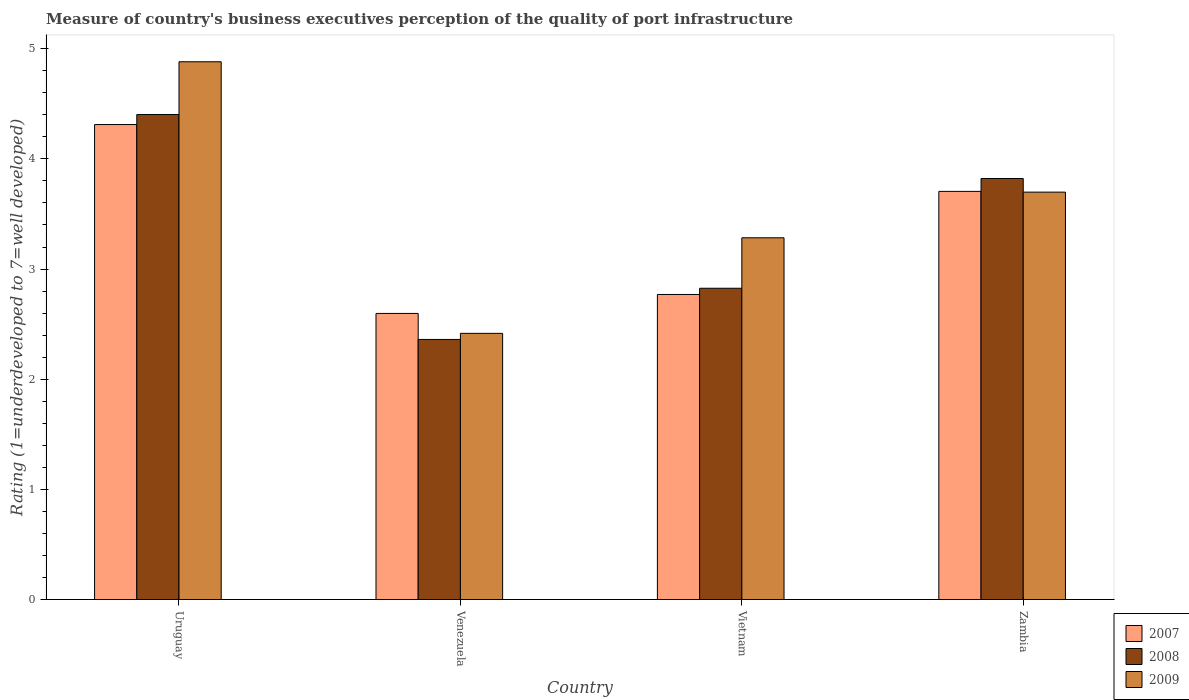How many different coloured bars are there?
Offer a very short reply. 3. How many groups of bars are there?
Keep it short and to the point. 4. Are the number of bars per tick equal to the number of legend labels?
Your answer should be compact. Yes. Are the number of bars on each tick of the X-axis equal?
Offer a very short reply. Yes. How many bars are there on the 1st tick from the right?
Keep it short and to the point. 3. What is the label of the 4th group of bars from the left?
Your answer should be very brief. Zambia. What is the ratings of the quality of port infrastructure in 2007 in Uruguay?
Your answer should be compact. 4.31. Across all countries, what is the maximum ratings of the quality of port infrastructure in 2007?
Offer a terse response. 4.31. Across all countries, what is the minimum ratings of the quality of port infrastructure in 2008?
Your response must be concise. 2.36. In which country was the ratings of the quality of port infrastructure in 2007 maximum?
Your response must be concise. Uruguay. In which country was the ratings of the quality of port infrastructure in 2007 minimum?
Give a very brief answer. Venezuela. What is the total ratings of the quality of port infrastructure in 2007 in the graph?
Provide a short and direct response. 13.38. What is the difference between the ratings of the quality of port infrastructure in 2009 in Uruguay and that in Zambia?
Your response must be concise. 1.18. What is the difference between the ratings of the quality of port infrastructure in 2007 in Venezuela and the ratings of the quality of port infrastructure in 2009 in Zambia?
Make the answer very short. -1.1. What is the average ratings of the quality of port infrastructure in 2009 per country?
Your answer should be compact. 3.57. What is the difference between the ratings of the quality of port infrastructure of/in 2009 and ratings of the quality of port infrastructure of/in 2008 in Vietnam?
Offer a very short reply. 0.46. In how many countries, is the ratings of the quality of port infrastructure in 2007 greater than 0.2?
Offer a terse response. 4. What is the ratio of the ratings of the quality of port infrastructure in 2009 in Uruguay to that in Vietnam?
Your answer should be very brief. 1.49. Is the ratings of the quality of port infrastructure in 2007 in Uruguay less than that in Venezuela?
Give a very brief answer. No. What is the difference between the highest and the second highest ratings of the quality of port infrastructure in 2007?
Provide a short and direct response. -0.94. What is the difference between the highest and the lowest ratings of the quality of port infrastructure in 2007?
Make the answer very short. 1.71. In how many countries, is the ratings of the quality of port infrastructure in 2007 greater than the average ratings of the quality of port infrastructure in 2007 taken over all countries?
Offer a terse response. 2. Is the sum of the ratings of the quality of port infrastructure in 2007 in Uruguay and Venezuela greater than the maximum ratings of the quality of port infrastructure in 2008 across all countries?
Make the answer very short. Yes. How many bars are there?
Make the answer very short. 12. Are all the bars in the graph horizontal?
Your response must be concise. No. Are the values on the major ticks of Y-axis written in scientific E-notation?
Provide a short and direct response. No. How are the legend labels stacked?
Provide a succinct answer. Vertical. What is the title of the graph?
Keep it short and to the point. Measure of country's business executives perception of the quality of port infrastructure. Does "1990" appear as one of the legend labels in the graph?
Give a very brief answer. No. What is the label or title of the Y-axis?
Ensure brevity in your answer.  Rating (1=underdeveloped to 7=well developed). What is the Rating (1=underdeveloped to 7=well developed) in 2007 in Uruguay?
Make the answer very short. 4.31. What is the Rating (1=underdeveloped to 7=well developed) in 2008 in Uruguay?
Your answer should be very brief. 4.4. What is the Rating (1=underdeveloped to 7=well developed) in 2009 in Uruguay?
Offer a very short reply. 4.88. What is the Rating (1=underdeveloped to 7=well developed) of 2007 in Venezuela?
Your answer should be compact. 2.6. What is the Rating (1=underdeveloped to 7=well developed) of 2008 in Venezuela?
Provide a succinct answer. 2.36. What is the Rating (1=underdeveloped to 7=well developed) of 2009 in Venezuela?
Provide a short and direct response. 2.42. What is the Rating (1=underdeveloped to 7=well developed) in 2007 in Vietnam?
Ensure brevity in your answer.  2.77. What is the Rating (1=underdeveloped to 7=well developed) of 2008 in Vietnam?
Provide a short and direct response. 2.83. What is the Rating (1=underdeveloped to 7=well developed) in 2009 in Vietnam?
Offer a terse response. 3.28. What is the Rating (1=underdeveloped to 7=well developed) in 2007 in Zambia?
Your answer should be compact. 3.7. What is the Rating (1=underdeveloped to 7=well developed) of 2008 in Zambia?
Ensure brevity in your answer.  3.82. What is the Rating (1=underdeveloped to 7=well developed) in 2009 in Zambia?
Your response must be concise. 3.7. Across all countries, what is the maximum Rating (1=underdeveloped to 7=well developed) in 2007?
Your answer should be very brief. 4.31. Across all countries, what is the maximum Rating (1=underdeveloped to 7=well developed) in 2008?
Your response must be concise. 4.4. Across all countries, what is the maximum Rating (1=underdeveloped to 7=well developed) in 2009?
Offer a terse response. 4.88. Across all countries, what is the minimum Rating (1=underdeveloped to 7=well developed) in 2007?
Your answer should be compact. 2.6. Across all countries, what is the minimum Rating (1=underdeveloped to 7=well developed) in 2008?
Ensure brevity in your answer.  2.36. Across all countries, what is the minimum Rating (1=underdeveloped to 7=well developed) in 2009?
Keep it short and to the point. 2.42. What is the total Rating (1=underdeveloped to 7=well developed) in 2007 in the graph?
Keep it short and to the point. 13.38. What is the total Rating (1=underdeveloped to 7=well developed) of 2008 in the graph?
Your answer should be compact. 13.41. What is the total Rating (1=underdeveloped to 7=well developed) in 2009 in the graph?
Ensure brevity in your answer.  14.28. What is the difference between the Rating (1=underdeveloped to 7=well developed) of 2007 in Uruguay and that in Venezuela?
Give a very brief answer. 1.71. What is the difference between the Rating (1=underdeveloped to 7=well developed) in 2008 in Uruguay and that in Venezuela?
Give a very brief answer. 2.04. What is the difference between the Rating (1=underdeveloped to 7=well developed) in 2009 in Uruguay and that in Venezuela?
Make the answer very short. 2.46. What is the difference between the Rating (1=underdeveloped to 7=well developed) of 2007 in Uruguay and that in Vietnam?
Offer a very short reply. 1.54. What is the difference between the Rating (1=underdeveloped to 7=well developed) in 2008 in Uruguay and that in Vietnam?
Ensure brevity in your answer.  1.58. What is the difference between the Rating (1=underdeveloped to 7=well developed) of 2009 in Uruguay and that in Vietnam?
Offer a very short reply. 1.6. What is the difference between the Rating (1=underdeveloped to 7=well developed) of 2007 in Uruguay and that in Zambia?
Provide a succinct answer. 0.61. What is the difference between the Rating (1=underdeveloped to 7=well developed) in 2008 in Uruguay and that in Zambia?
Your answer should be very brief. 0.58. What is the difference between the Rating (1=underdeveloped to 7=well developed) of 2009 in Uruguay and that in Zambia?
Provide a succinct answer. 1.18. What is the difference between the Rating (1=underdeveloped to 7=well developed) in 2007 in Venezuela and that in Vietnam?
Make the answer very short. -0.17. What is the difference between the Rating (1=underdeveloped to 7=well developed) in 2008 in Venezuela and that in Vietnam?
Offer a terse response. -0.46. What is the difference between the Rating (1=underdeveloped to 7=well developed) in 2009 in Venezuela and that in Vietnam?
Offer a terse response. -0.87. What is the difference between the Rating (1=underdeveloped to 7=well developed) of 2007 in Venezuela and that in Zambia?
Keep it short and to the point. -1.11. What is the difference between the Rating (1=underdeveloped to 7=well developed) of 2008 in Venezuela and that in Zambia?
Your response must be concise. -1.46. What is the difference between the Rating (1=underdeveloped to 7=well developed) of 2009 in Venezuela and that in Zambia?
Provide a short and direct response. -1.28. What is the difference between the Rating (1=underdeveloped to 7=well developed) of 2007 in Vietnam and that in Zambia?
Provide a succinct answer. -0.94. What is the difference between the Rating (1=underdeveloped to 7=well developed) of 2008 in Vietnam and that in Zambia?
Keep it short and to the point. -1. What is the difference between the Rating (1=underdeveloped to 7=well developed) in 2009 in Vietnam and that in Zambia?
Your response must be concise. -0.41. What is the difference between the Rating (1=underdeveloped to 7=well developed) of 2007 in Uruguay and the Rating (1=underdeveloped to 7=well developed) of 2008 in Venezuela?
Offer a very short reply. 1.95. What is the difference between the Rating (1=underdeveloped to 7=well developed) in 2007 in Uruguay and the Rating (1=underdeveloped to 7=well developed) in 2009 in Venezuela?
Keep it short and to the point. 1.9. What is the difference between the Rating (1=underdeveloped to 7=well developed) in 2008 in Uruguay and the Rating (1=underdeveloped to 7=well developed) in 2009 in Venezuela?
Give a very brief answer. 1.99. What is the difference between the Rating (1=underdeveloped to 7=well developed) of 2007 in Uruguay and the Rating (1=underdeveloped to 7=well developed) of 2008 in Vietnam?
Your answer should be compact. 1.49. What is the difference between the Rating (1=underdeveloped to 7=well developed) in 2007 in Uruguay and the Rating (1=underdeveloped to 7=well developed) in 2009 in Vietnam?
Offer a terse response. 1.03. What is the difference between the Rating (1=underdeveloped to 7=well developed) in 2008 in Uruguay and the Rating (1=underdeveloped to 7=well developed) in 2009 in Vietnam?
Your response must be concise. 1.12. What is the difference between the Rating (1=underdeveloped to 7=well developed) of 2007 in Uruguay and the Rating (1=underdeveloped to 7=well developed) of 2008 in Zambia?
Your answer should be compact. 0.49. What is the difference between the Rating (1=underdeveloped to 7=well developed) in 2007 in Uruguay and the Rating (1=underdeveloped to 7=well developed) in 2009 in Zambia?
Your response must be concise. 0.61. What is the difference between the Rating (1=underdeveloped to 7=well developed) in 2008 in Uruguay and the Rating (1=underdeveloped to 7=well developed) in 2009 in Zambia?
Provide a succinct answer. 0.7. What is the difference between the Rating (1=underdeveloped to 7=well developed) of 2007 in Venezuela and the Rating (1=underdeveloped to 7=well developed) of 2008 in Vietnam?
Keep it short and to the point. -0.23. What is the difference between the Rating (1=underdeveloped to 7=well developed) in 2007 in Venezuela and the Rating (1=underdeveloped to 7=well developed) in 2009 in Vietnam?
Your answer should be compact. -0.69. What is the difference between the Rating (1=underdeveloped to 7=well developed) of 2008 in Venezuela and the Rating (1=underdeveloped to 7=well developed) of 2009 in Vietnam?
Make the answer very short. -0.92. What is the difference between the Rating (1=underdeveloped to 7=well developed) of 2007 in Venezuela and the Rating (1=underdeveloped to 7=well developed) of 2008 in Zambia?
Your answer should be very brief. -1.22. What is the difference between the Rating (1=underdeveloped to 7=well developed) of 2007 in Venezuela and the Rating (1=underdeveloped to 7=well developed) of 2009 in Zambia?
Offer a very short reply. -1.1. What is the difference between the Rating (1=underdeveloped to 7=well developed) of 2008 in Venezuela and the Rating (1=underdeveloped to 7=well developed) of 2009 in Zambia?
Give a very brief answer. -1.34. What is the difference between the Rating (1=underdeveloped to 7=well developed) of 2007 in Vietnam and the Rating (1=underdeveloped to 7=well developed) of 2008 in Zambia?
Your answer should be compact. -1.05. What is the difference between the Rating (1=underdeveloped to 7=well developed) of 2007 in Vietnam and the Rating (1=underdeveloped to 7=well developed) of 2009 in Zambia?
Your response must be concise. -0.93. What is the difference between the Rating (1=underdeveloped to 7=well developed) in 2008 in Vietnam and the Rating (1=underdeveloped to 7=well developed) in 2009 in Zambia?
Your answer should be compact. -0.87. What is the average Rating (1=underdeveloped to 7=well developed) in 2007 per country?
Your answer should be compact. 3.35. What is the average Rating (1=underdeveloped to 7=well developed) of 2008 per country?
Give a very brief answer. 3.35. What is the average Rating (1=underdeveloped to 7=well developed) in 2009 per country?
Keep it short and to the point. 3.57. What is the difference between the Rating (1=underdeveloped to 7=well developed) in 2007 and Rating (1=underdeveloped to 7=well developed) in 2008 in Uruguay?
Your answer should be very brief. -0.09. What is the difference between the Rating (1=underdeveloped to 7=well developed) of 2007 and Rating (1=underdeveloped to 7=well developed) of 2009 in Uruguay?
Ensure brevity in your answer.  -0.57. What is the difference between the Rating (1=underdeveloped to 7=well developed) in 2008 and Rating (1=underdeveloped to 7=well developed) in 2009 in Uruguay?
Your answer should be very brief. -0.48. What is the difference between the Rating (1=underdeveloped to 7=well developed) of 2007 and Rating (1=underdeveloped to 7=well developed) of 2008 in Venezuela?
Make the answer very short. 0.24. What is the difference between the Rating (1=underdeveloped to 7=well developed) of 2007 and Rating (1=underdeveloped to 7=well developed) of 2009 in Venezuela?
Your answer should be compact. 0.18. What is the difference between the Rating (1=underdeveloped to 7=well developed) in 2008 and Rating (1=underdeveloped to 7=well developed) in 2009 in Venezuela?
Keep it short and to the point. -0.06. What is the difference between the Rating (1=underdeveloped to 7=well developed) in 2007 and Rating (1=underdeveloped to 7=well developed) in 2008 in Vietnam?
Your answer should be very brief. -0.06. What is the difference between the Rating (1=underdeveloped to 7=well developed) in 2007 and Rating (1=underdeveloped to 7=well developed) in 2009 in Vietnam?
Your answer should be very brief. -0.51. What is the difference between the Rating (1=underdeveloped to 7=well developed) in 2008 and Rating (1=underdeveloped to 7=well developed) in 2009 in Vietnam?
Your response must be concise. -0.46. What is the difference between the Rating (1=underdeveloped to 7=well developed) in 2007 and Rating (1=underdeveloped to 7=well developed) in 2008 in Zambia?
Your answer should be very brief. -0.12. What is the difference between the Rating (1=underdeveloped to 7=well developed) of 2007 and Rating (1=underdeveloped to 7=well developed) of 2009 in Zambia?
Offer a terse response. 0.01. What is the difference between the Rating (1=underdeveloped to 7=well developed) in 2008 and Rating (1=underdeveloped to 7=well developed) in 2009 in Zambia?
Your answer should be very brief. 0.12. What is the ratio of the Rating (1=underdeveloped to 7=well developed) of 2007 in Uruguay to that in Venezuela?
Provide a short and direct response. 1.66. What is the ratio of the Rating (1=underdeveloped to 7=well developed) in 2008 in Uruguay to that in Venezuela?
Your answer should be very brief. 1.86. What is the ratio of the Rating (1=underdeveloped to 7=well developed) in 2009 in Uruguay to that in Venezuela?
Your answer should be very brief. 2.02. What is the ratio of the Rating (1=underdeveloped to 7=well developed) of 2007 in Uruguay to that in Vietnam?
Make the answer very short. 1.56. What is the ratio of the Rating (1=underdeveloped to 7=well developed) of 2008 in Uruguay to that in Vietnam?
Offer a very short reply. 1.56. What is the ratio of the Rating (1=underdeveloped to 7=well developed) in 2009 in Uruguay to that in Vietnam?
Your answer should be very brief. 1.49. What is the ratio of the Rating (1=underdeveloped to 7=well developed) in 2007 in Uruguay to that in Zambia?
Your answer should be very brief. 1.16. What is the ratio of the Rating (1=underdeveloped to 7=well developed) of 2008 in Uruguay to that in Zambia?
Give a very brief answer. 1.15. What is the ratio of the Rating (1=underdeveloped to 7=well developed) in 2009 in Uruguay to that in Zambia?
Give a very brief answer. 1.32. What is the ratio of the Rating (1=underdeveloped to 7=well developed) in 2007 in Venezuela to that in Vietnam?
Your answer should be compact. 0.94. What is the ratio of the Rating (1=underdeveloped to 7=well developed) in 2008 in Venezuela to that in Vietnam?
Keep it short and to the point. 0.84. What is the ratio of the Rating (1=underdeveloped to 7=well developed) in 2009 in Venezuela to that in Vietnam?
Offer a very short reply. 0.74. What is the ratio of the Rating (1=underdeveloped to 7=well developed) of 2007 in Venezuela to that in Zambia?
Ensure brevity in your answer.  0.7. What is the ratio of the Rating (1=underdeveloped to 7=well developed) in 2008 in Venezuela to that in Zambia?
Provide a short and direct response. 0.62. What is the ratio of the Rating (1=underdeveloped to 7=well developed) of 2009 in Venezuela to that in Zambia?
Offer a terse response. 0.65. What is the ratio of the Rating (1=underdeveloped to 7=well developed) of 2007 in Vietnam to that in Zambia?
Ensure brevity in your answer.  0.75. What is the ratio of the Rating (1=underdeveloped to 7=well developed) of 2008 in Vietnam to that in Zambia?
Ensure brevity in your answer.  0.74. What is the ratio of the Rating (1=underdeveloped to 7=well developed) in 2009 in Vietnam to that in Zambia?
Give a very brief answer. 0.89. What is the difference between the highest and the second highest Rating (1=underdeveloped to 7=well developed) in 2007?
Your response must be concise. 0.61. What is the difference between the highest and the second highest Rating (1=underdeveloped to 7=well developed) of 2008?
Provide a succinct answer. 0.58. What is the difference between the highest and the second highest Rating (1=underdeveloped to 7=well developed) in 2009?
Offer a terse response. 1.18. What is the difference between the highest and the lowest Rating (1=underdeveloped to 7=well developed) of 2007?
Give a very brief answer. 1.71. What is the difference between the highest and the lowest Rating (1=underdeveloped to 7=well developed) of 2008?
Ensure brevity in your answer.  2.04. What is the difference between the highest and the lowest Rating (1=underdeveloped to 7=well developed) of 2009?
Offer a very short reply. 2.46. 